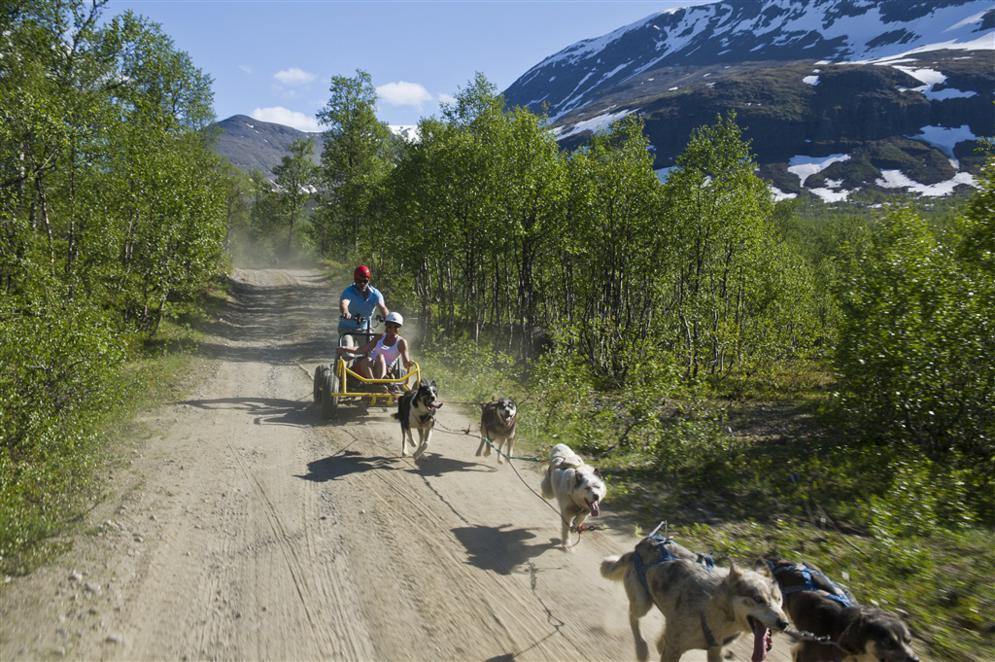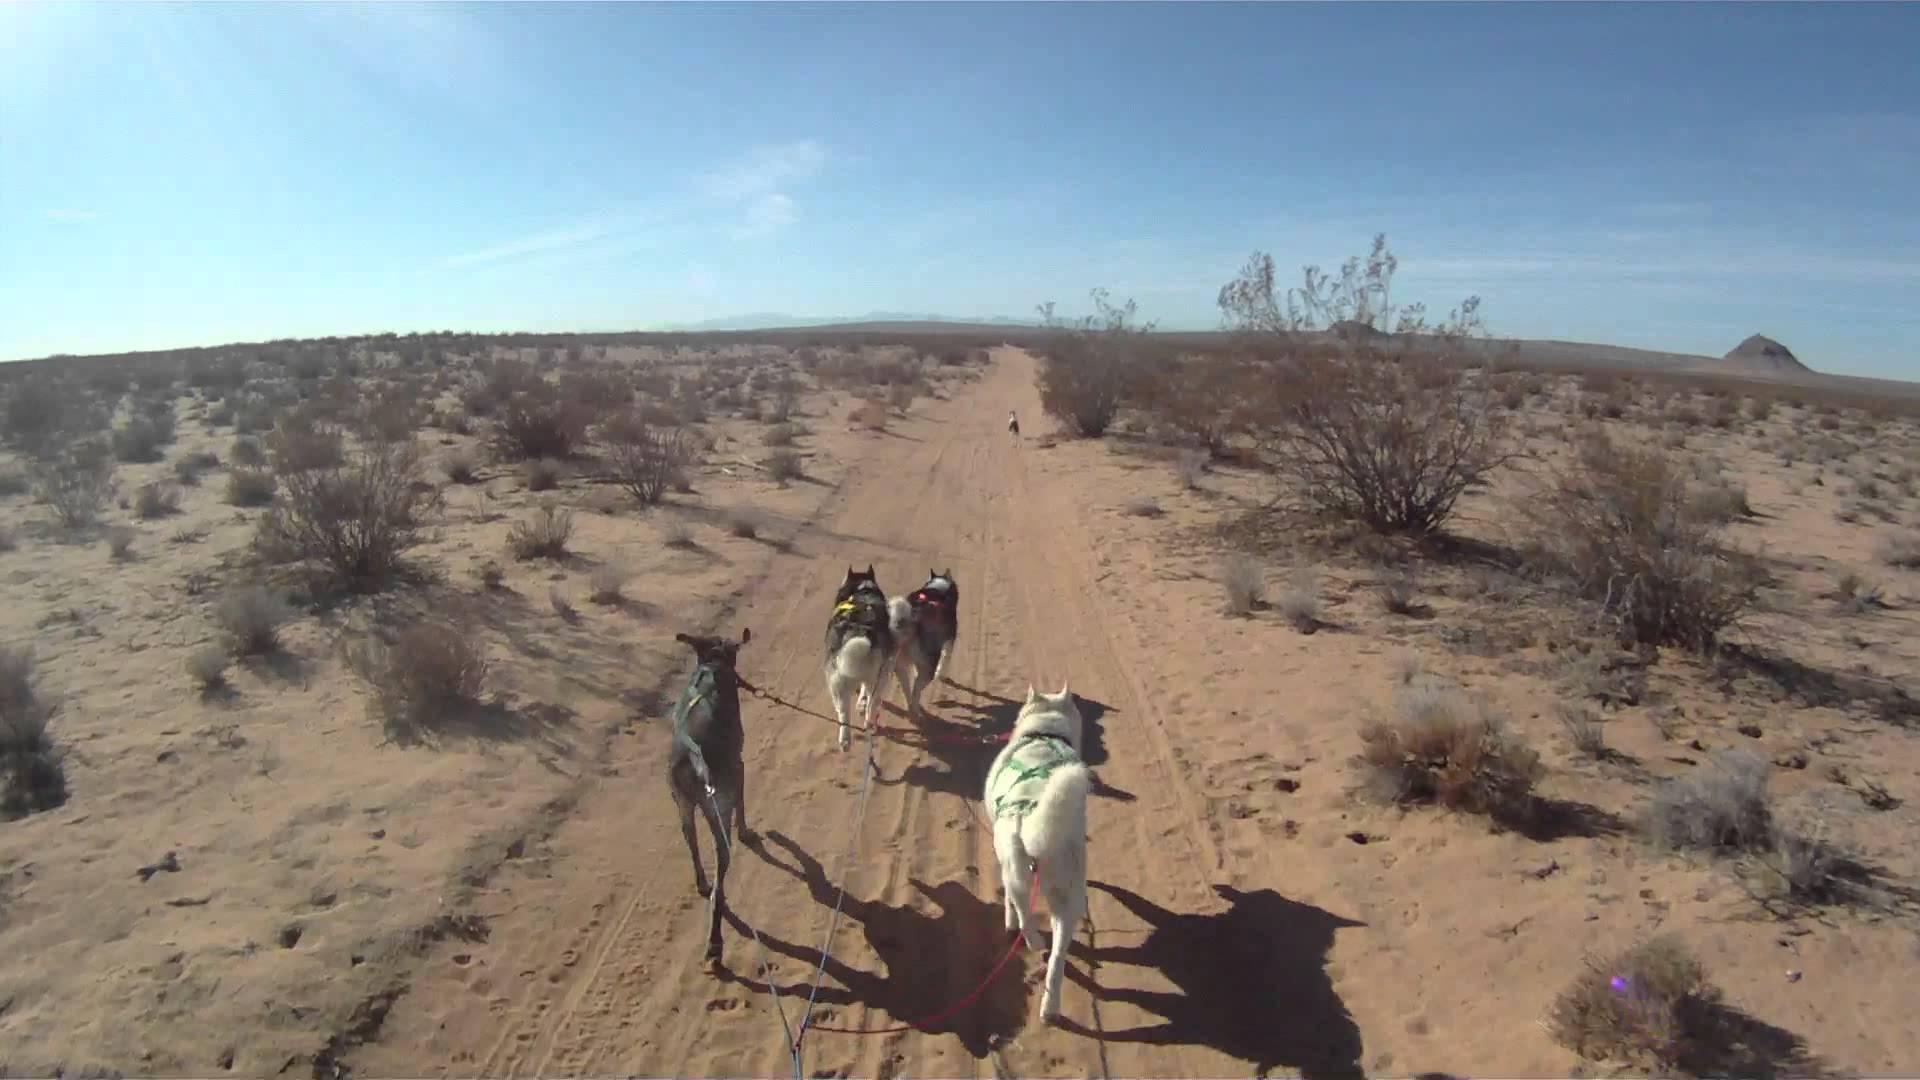The first image is the image on the left, the second image is the image on the right. Assess this claim about the two images: "The image on the left shows a dog team running in snow.". Correct or not? Answer yes or no. No. The first image is the image on the left, the second image is the image on the right. For the images displayed, is the sentence "One dog team is crossing snowy ground while the other is hitched to a wheeled cart on a dry road." factually correct? Answer yes or no. No. 